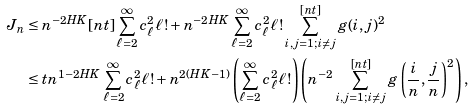<formula> <loc_0><loc_0><loc_500><loc_500>J _ { n } & \leq n ^ { - 2 H K } { [ n t ] } \sum _ { \ell = 2 } ^ { \infty } c _ { \ell } ^ { 2 } \ell ! + n ^ { - 2 H K } \sum _ { \ell = 2 } ^ { \infty } c _ { \ell } ^ { 2 } \ell ! \sum _ { i , j = 1 ; i \not = j } ^ { [ n t ] } g ( i , j ) ^ { 2 } \\ & \leq t n ^ { 1 - 2 H K } \sum _ { \ell = 2 } ^ { \infty } c _ { \ell } ^ { 2 } \ell ! + n ^ { 2 ( H K - 1 ) } \left ( \sum _ { \ell = 2 } ^ { \infty } c _ { \ell } ^ { 2 } { \ell } ! \right ) \left ( n ^ { - 2 } \sum _ { i , j = 1 ; i \not = j } ^ { [ n t ] } g \left ( \frac { i } { n } , \frac { j } { n } \right ) ^ { 2 } \right ) ,</formula> 